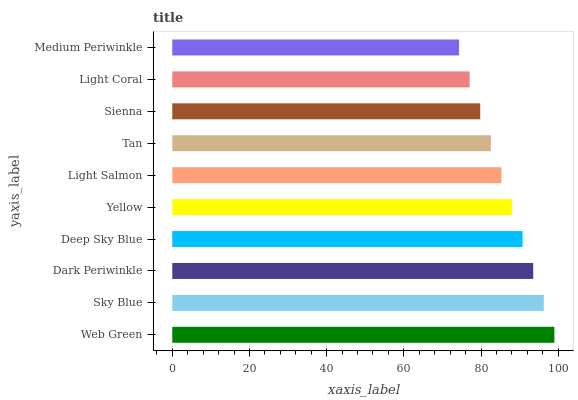Is Medium Periwinkle the minimum?
Answer yes or no. Yes. Is Web Green the maximum?
Answer yes or no. Yes. Is Sky Blue the minimum?
Answer yes or no. No. Is Sky Blue the maximum?
Answer yes or no. No. Is Web Green greater than Sky Blue?
Answer yes or no. Yes. Is Sky Blue less than Web Green?
Answer yes or no. Yes. Is Sky Blue greater than Web Green?
Answer yes or no. No. Is Web Green less than Sky Blue?
Answer yes or no. No. Is Yellow the high median?
Answer yes or no. Yes. Is Light Salmon the low median?
Answer yes or no. Yes. Is Sky Blue the high median?
Answer yes or no. No. Is Web Green the low median?
Answer yes or no. No. 